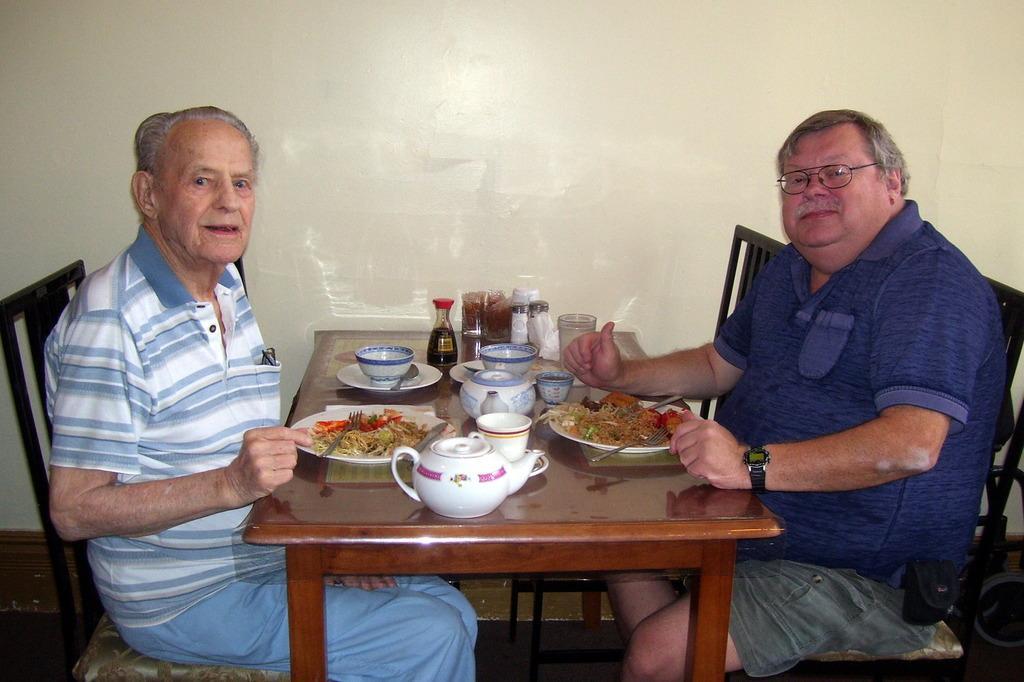Could you give a brief overview of what you see in this image? In this picture we can see two men sitting on chair and in front of them there is table and on table we can see tea pot, cup, bowl, plate, spoon, fork, food, bottles and in background we can see wall here this two men are smiling. 